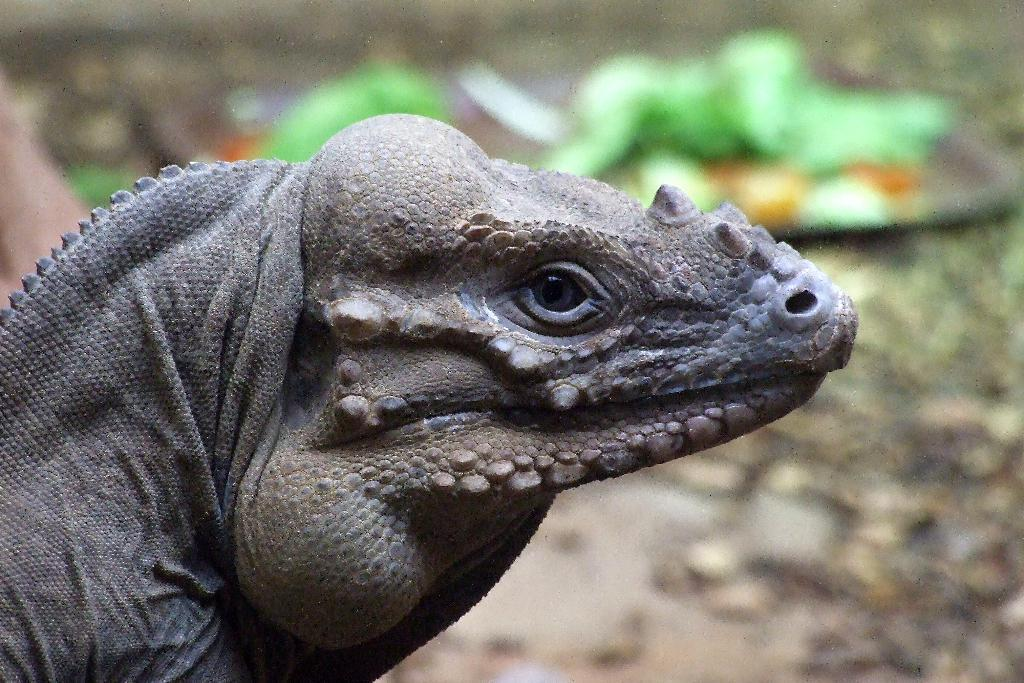What type of creature is present in the image? There is an animal in the image. Can you describe the background of the image? The background of the image is blurry. How many dolls are supporting the animal in the image? There are no dolls present in the image, and the animal is not being supported by any dolls. 